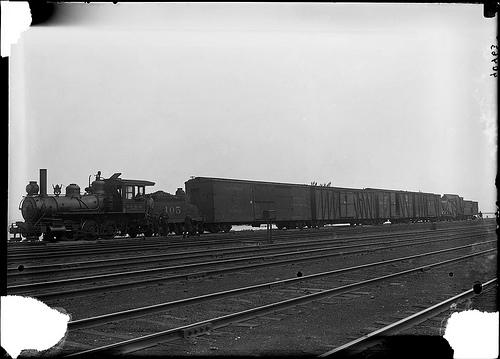Is the sun shining?
Keep it brief. No. What speed is the train moving at?
Be succinct. Slow. Is this picture in color?
Concise answer only. No. Is the sun shining?
Answer briefly. No. 